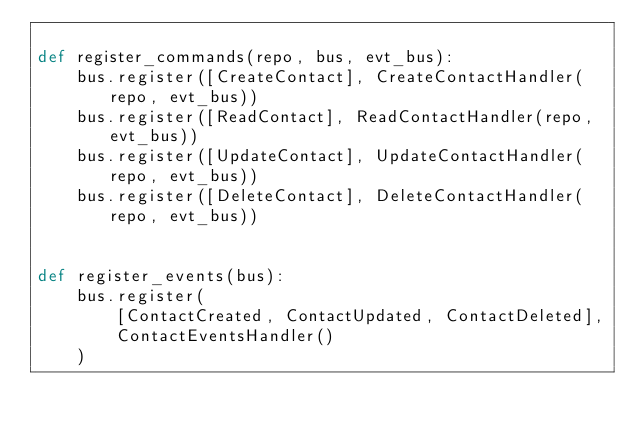<code> <loc_0><loc_0><loc_500><loc_500><_Python_>
def register_commands(repo, bus, evt_bus):
    bus.register([CreateContact], CreateContactHandler(repo, evt_bus))
    bus.register([ReadContact], ReadContactHandler(repo, evt_bus))
    bus.register([UpdateContact], UpdateContactHandler(repo, evt_bus))
    bus.register([DeleteContact], DeleteContactHandler(repo, evt_bus))


def register_events(bus):
    bus.register(
        [ContactCreated, ContactUpdated, ContactDeleted],
        ContactEventsHandler()
    )
</code> 